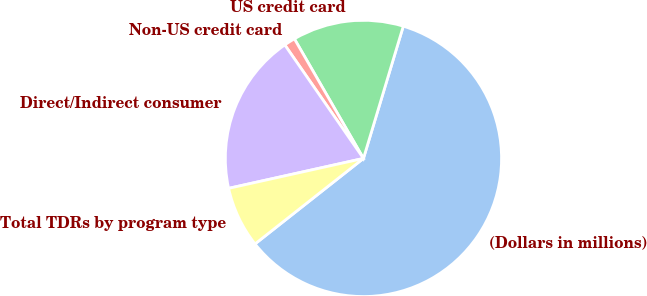<chart> <loc_0><loc_0><loc_500><loc_500><pie_chart><fcel>(Dollars in millions)<fcel>US credit card<fcel>Non-US credit card<fcel>Direct/Indirect consumer<fcel>Total TDRs by program type<nl><fcel>59.71%<fcel>12.99%<fcel>1.31%<fcel>18.83%<fcel>7.15%<nl></chart> 